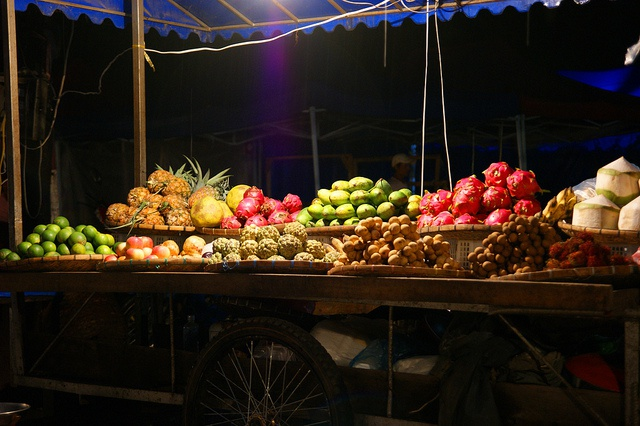Describe the objects in this image and their specific colors. I can see apple in black and olive tones, apple in black, gold, orange, olive, and khaki tones, orange in black, khaki, orange, and gold tones, apple in black, red, salmon, and brown tones, and apple in black, khaki, red, and orange tones in this image. 